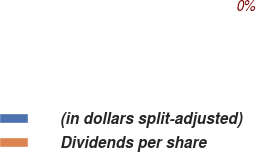<chart> <loc_0><loc_0><loc_500><loc_500><pie_chart><fcel>(in dollars split-adjusted)<fcel>Dividends per share<nl><fcel>100.0%<fcel>0.0%<nl></chart> 